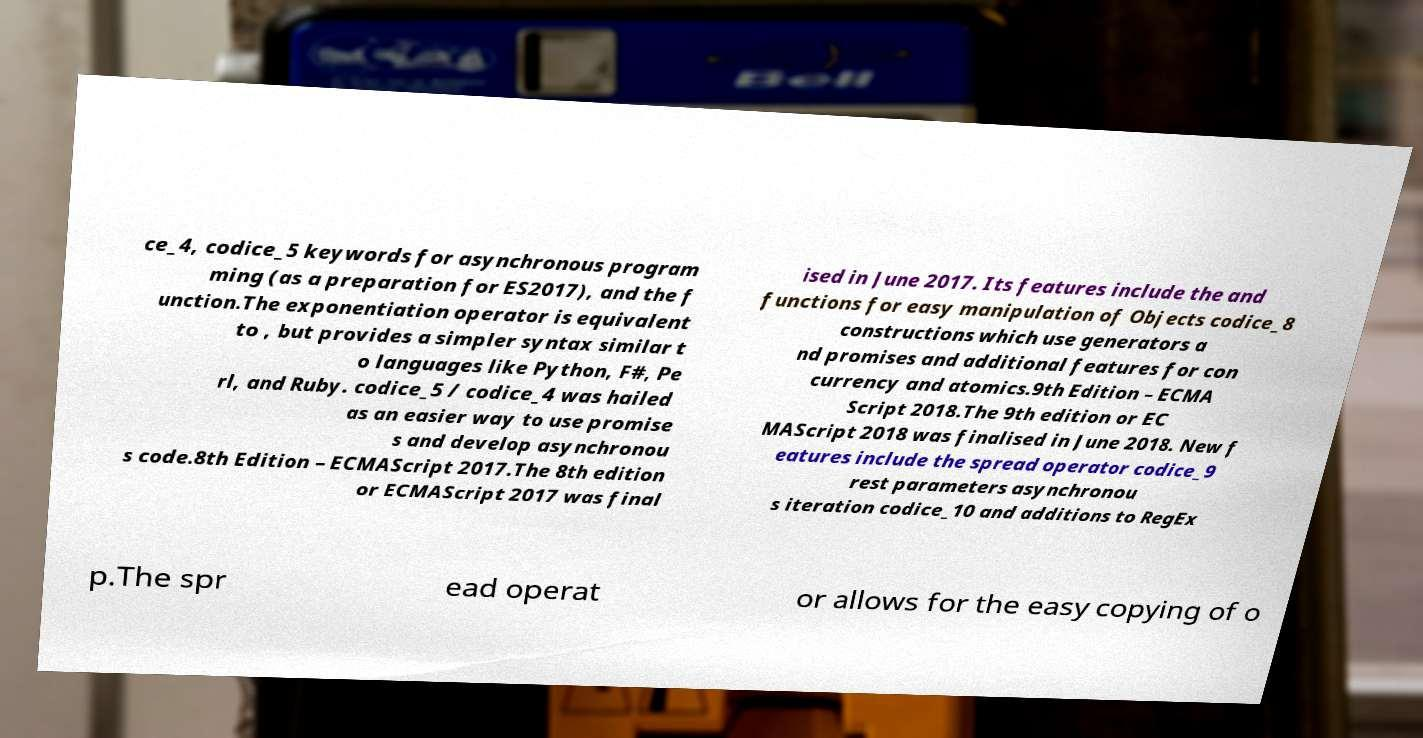Could you extract and type out the text from this image? ce_4, codice_5 keywords for asynchronous program ming (as a preparation for ES2017), and the f unction.The exponentiation operator is equivalent to , but provides a simpler syntax similar t o languages like Python, F#, Pe rl, and Ruby. codice_5 / codice_4 was hailed as an easier way to use promise s and develop asynchronou s code.8th Edition – ECMAScript 2017.The 8th edition or ECMAScript 2017 was final ised in June 2017. Its features include the and functions for easy manipulation of Objects codice_8 constructions which use generators a nd promises and additional features for con currency and atomics.9th Edition – ECMA Script 2018.The 9th edition or EC MAScript 2018 was finalised in June 2018. New f eatures include the spread operator codice_9 rest parameters asynchronou s iteration codice_10 and additions to RegEx p.The spr ead operat or allows for the easy copying of o 